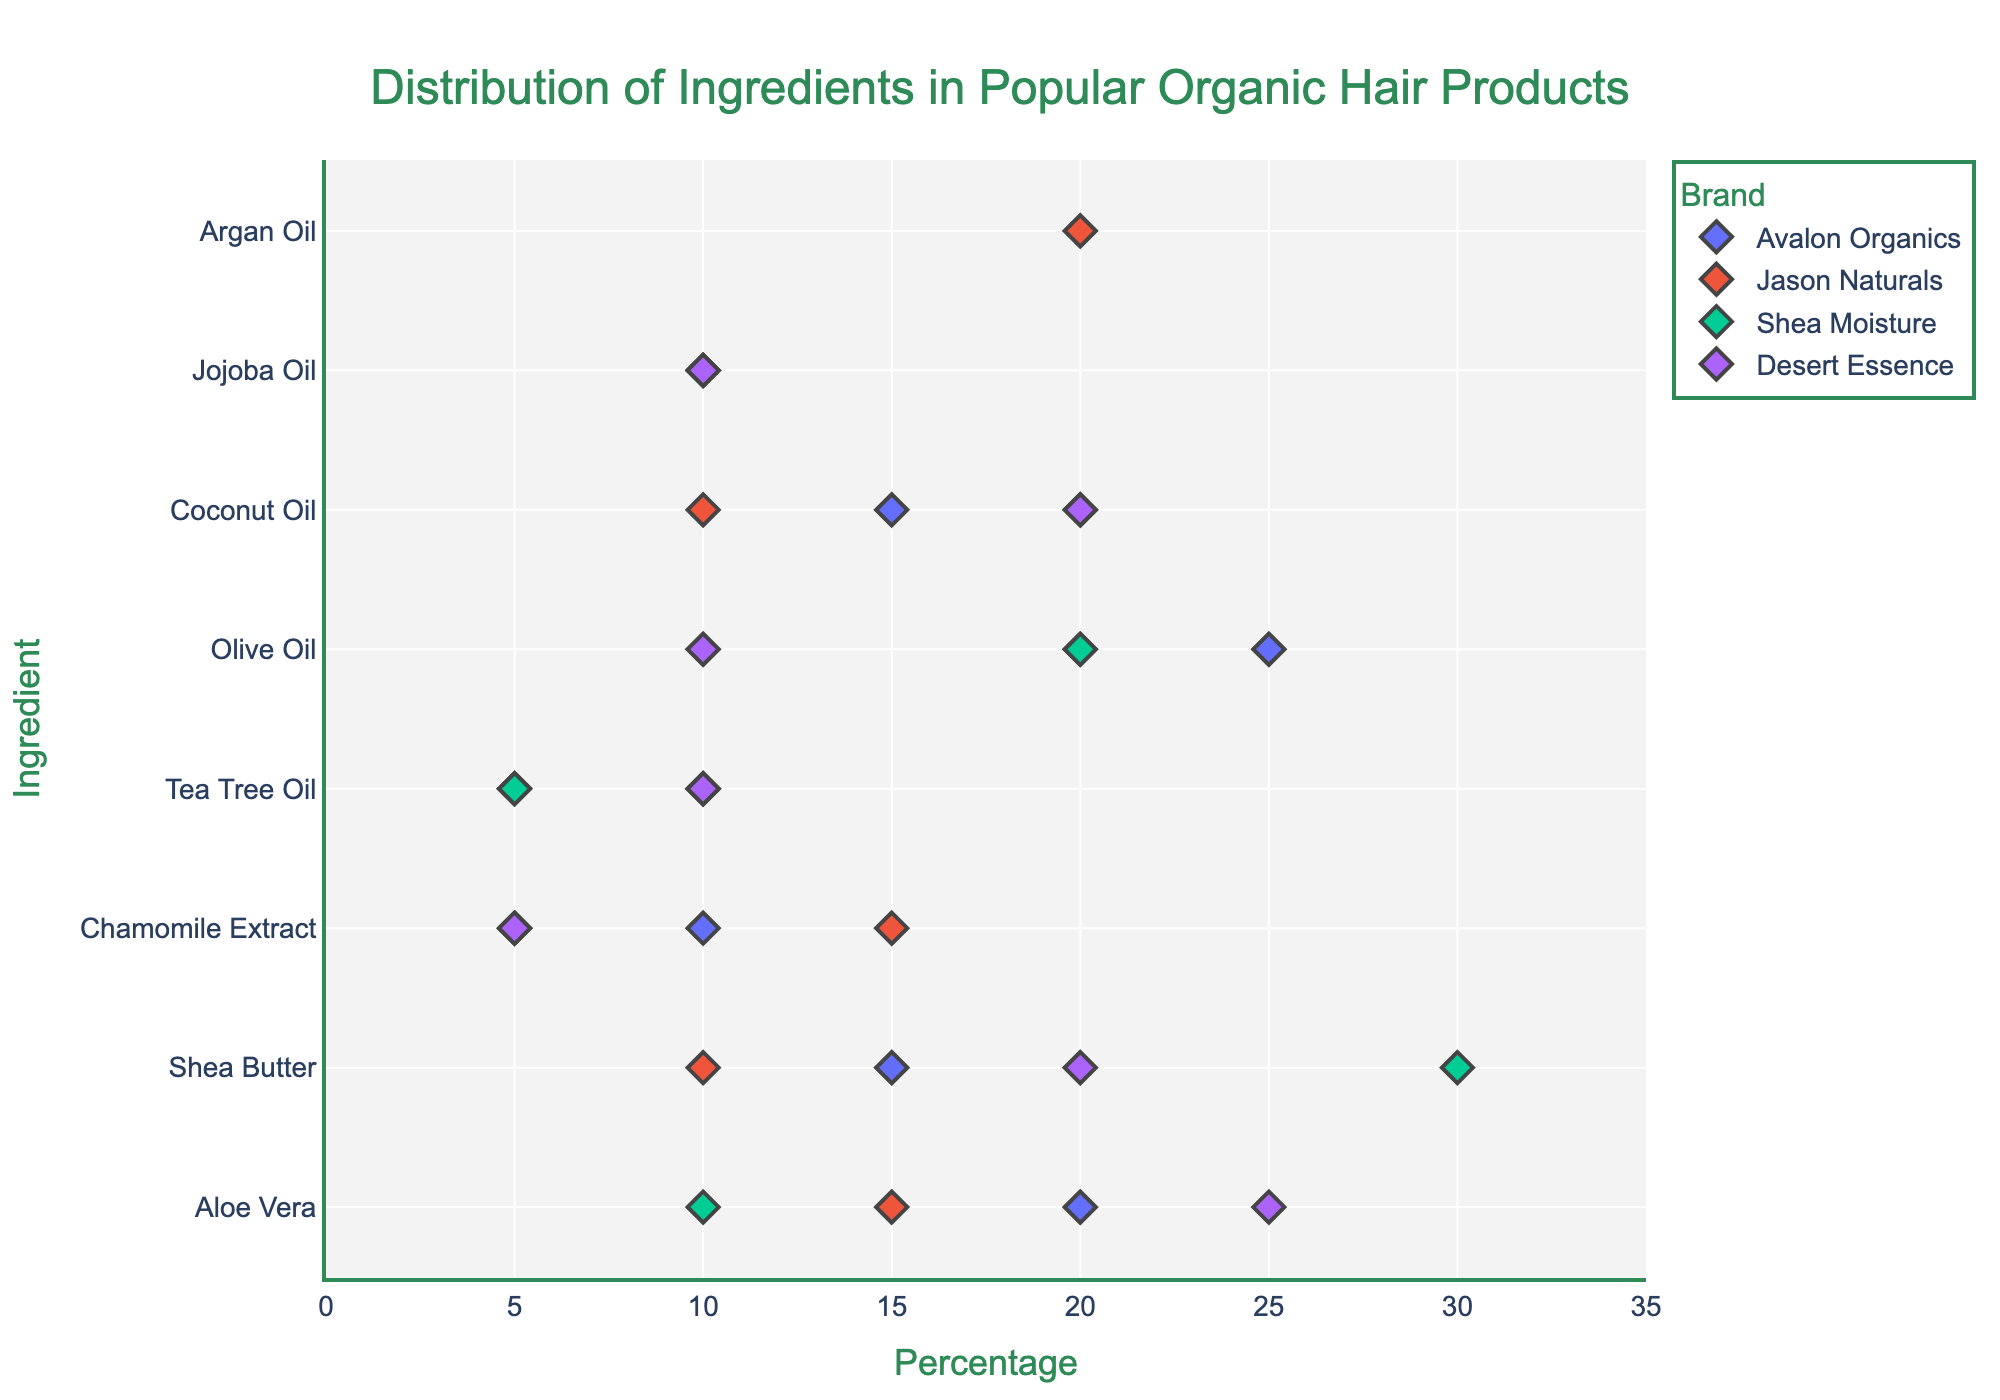What's the title of the plot? The title of a plot is usually located at the top and provides an overview of the plot's content. In this case, the title is 'Distribution of Ingredients in Popular Organic Hair Products.'
Answer: Distribution of Ingredients in Popular Organic Hair Products Which brand has the highest percentage of Aloe Vera? To determine this, look at the point corresponding to Aloe Vera and see which brand’s marker is furthest to the right. The Desert Essence brand has the highest percentage at 25%.
Answer: Desert Essence Which ingredient is most frequently used across all brands? The ingredient most frequently used can be identified by seeing which ingredient appears most often (most markers in a row) in the y-axis. Aloe Vera and Shea Butter are used by all listed brands.
Answer: Aloe Vera and Shea Butter What is the range of percentages for Coconut Oil across all brands? To find this, identify the minimum and maximum percentage values for Coconut Oil from the points in the plot. The range is from 10% to 20%.
Answer: 10% to 20% Which brand has the most balanced distribution of ingredients (least variation in percentages)? Balance means that the percentages of the ingredients are close to each other. By observing the spread of points along the X-axis for each brand, Jason Naturals appears to have ingredients percentages more tightly clustered compared to other brands.
Answer: Jason Naturals How many ingredients contain Tea Tree Oil across all brands? Inspect the plot and count the markers on the y-axis at Tea Tree Oil. There are markers for Avalon Organics, Jason Naturals, Shea Moisture, and Desert Essence, making the count 4.
Answer: 4 Which brand has the highest percentage of a single ingredient and which ingredient is it? Check for the highest single point across all brands. Shea Moisture has the highest single percentage at 30% for Shea Butter.
Answer: Shea Moisture, Shea Butter Compare the percentage of Chamomile Extract between Jason Naturals and Avalon Organics. Which brand uses more? Look at the points for Chamomile Extract for both brands; Jason Naturals has 15%, and Avalon Organics has 10%, thus Jason Naturals uses more.
Answer: Jason Naturals What's the average percentage of Olive Oil across all brands? Identify the percentages of Olive Oil per brand: 25% (Avalon Organics), 20% (Jason Naturals), 20% (Shea Moisture), and 10% (Desert Essence). Summing them up (25 + 20 + 20 + 10) we get 75, and the average is 75/4 = 18.75
Answer: 18.75 What is the total number of unique ingredients used in the products? Count the unique ingredients listed on the y-axis: Aloe Vera, Shea Butter, Chamomile Extract, Tea Tree Oil, Olive Oil, Coconut Oil, Jojoba Oil, Argan Oil. This totals to 8 unique ingredients.
Answer: 8 